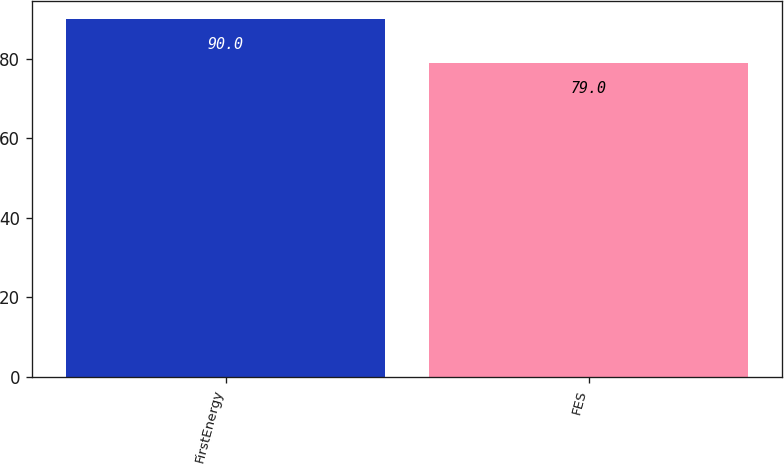Convert chart to OTSL. <chart><loc_0><loc_0><loc_500><loc_500><bar_chart><fcel>FirstEnergy<fcel>FES<nl><fcel>90<fcel>79<nl></chart> 